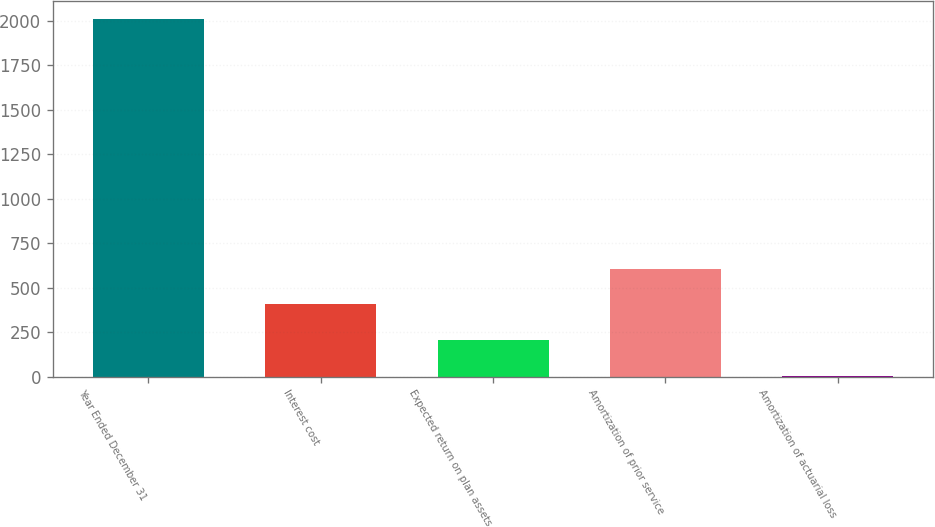Convert chart to OTSL. <chart><loc_0><loc_0><loc_500><loc_500><bar_chart><fcel>Year Ended December 31<fcel>Interest cost<fcel>Expected return on plan assets<fcel>Amortization of prior service<fcel>Amortization of actuarial loss<nl><fcel>2012<fcel>407.2<fcel>206.6<fcel>607.8<fcel>6<nl></chart> 